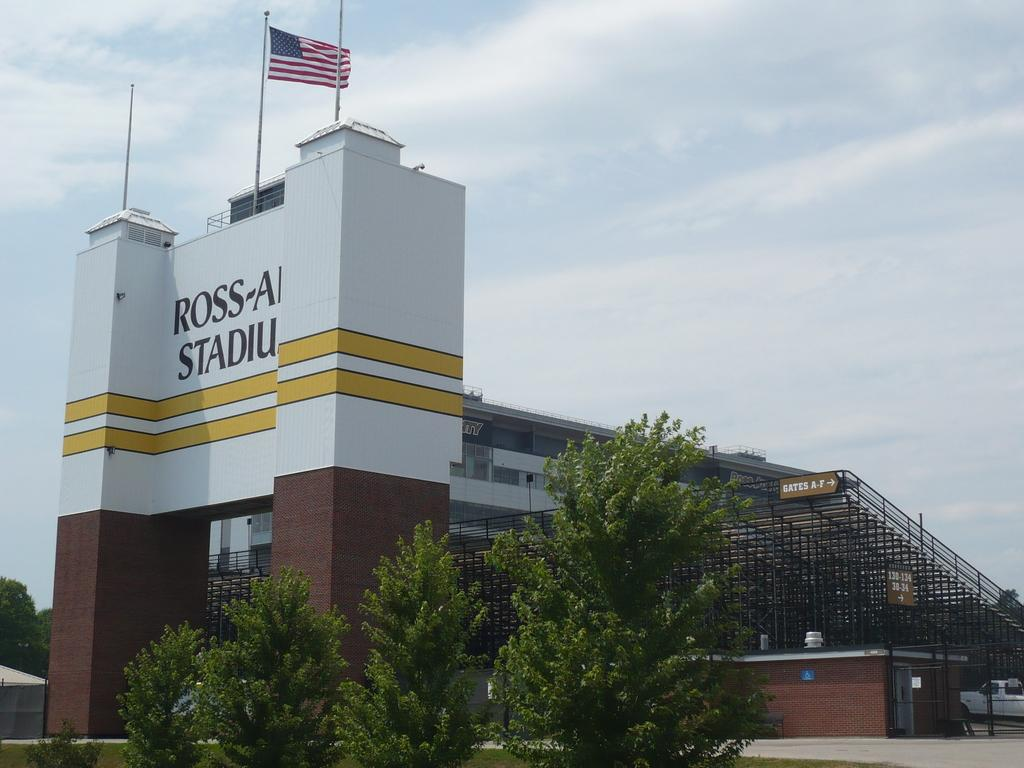<image>
Describe the image concisely. White and yellow sign in front of a building that says ROSS on it. 